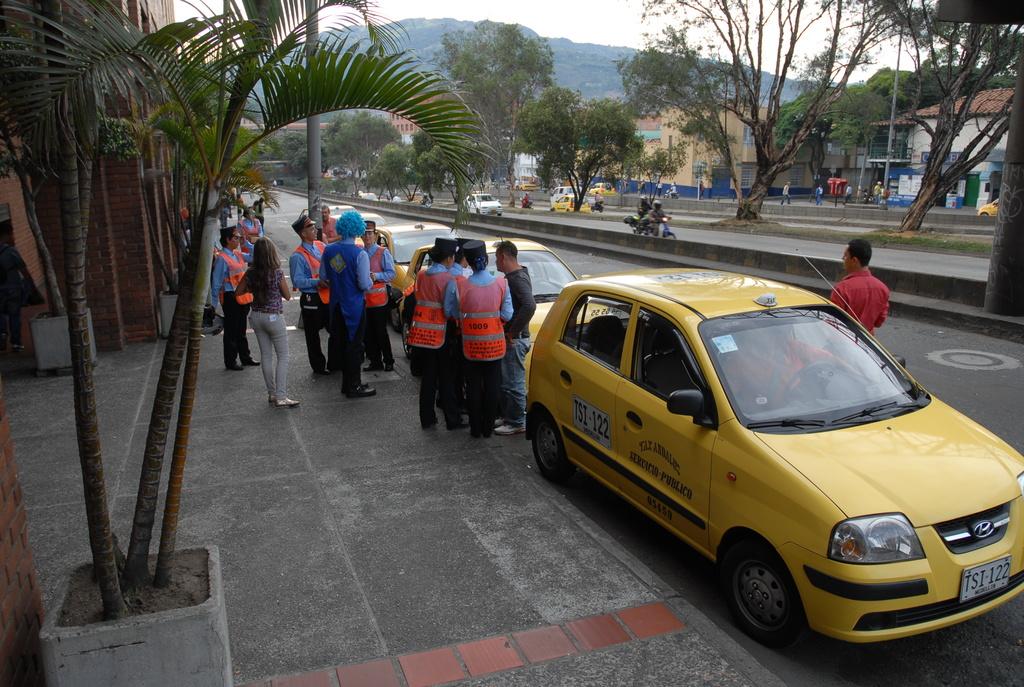What are the last two numbers on the yellow car?
Give a very brief answer. 22. Is that a taxi?
Your answer should be compact. Yes. 